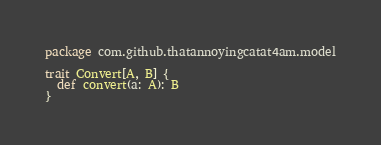<code> <loc_0><loc_0><loc_500><loc_500><_Scala_>package com.github.thatannoyingcatat4am.model

trait Convert[A, B] {
  def convert(a: A): B
}
</code> 